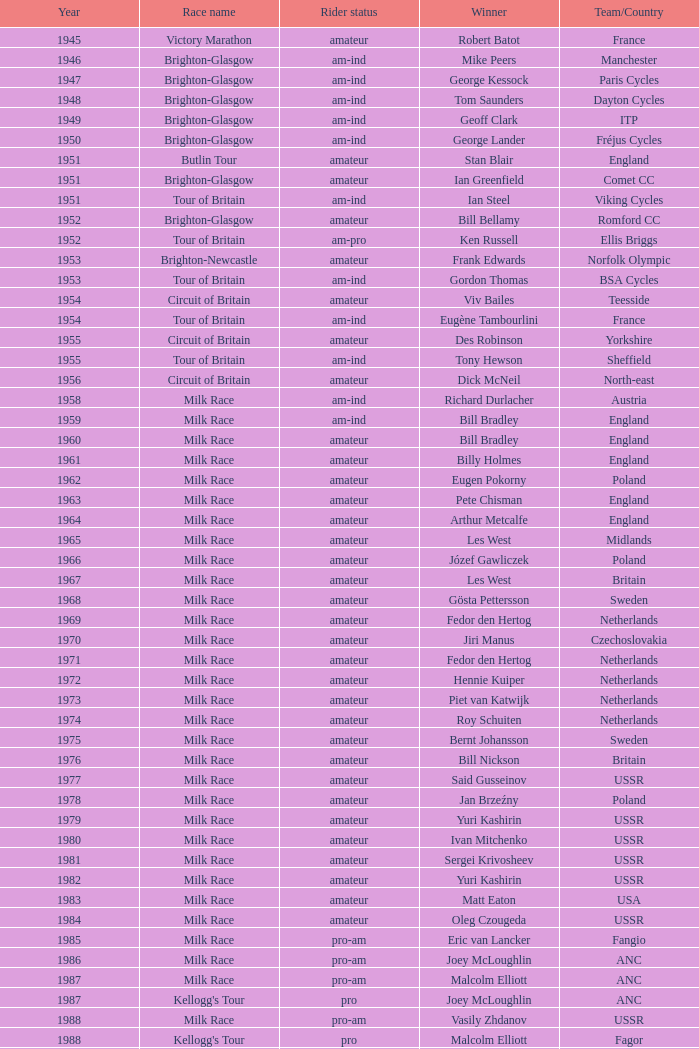What ream played later than 1958 in the kellogg's tour? ANC, Fagor, Z-Peugeot, Weinnmann-SMM, Motorola, Motorola, Motorola, Lampre. 